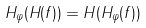<formula> <loc_0><loc_0><loc_500><loc_500>H _ { \varphi } ( H ( f ) ) = H ( H _ { \varphi } ( f ) )</formula> 